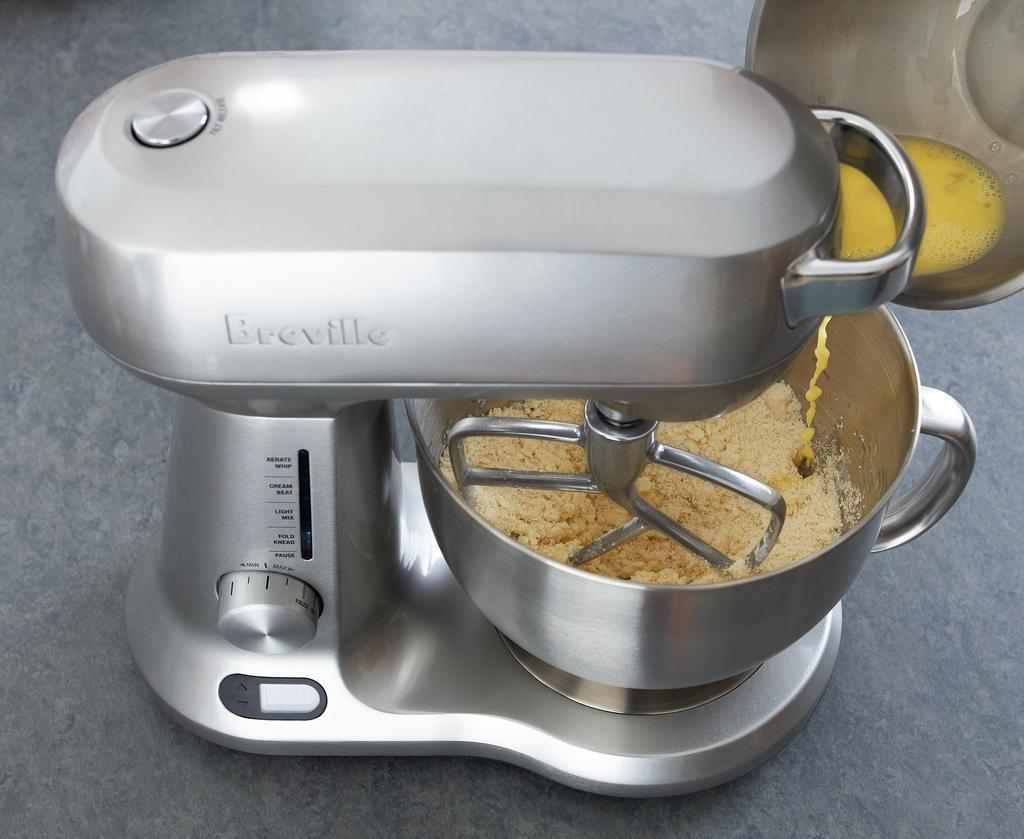<image>
Relay a brief, clear account of the picture shown. a Breville stand mixer in silver with settings that include Fold Mix, Cream Beat, Pause, Light Mix, and Aerate Whip. 